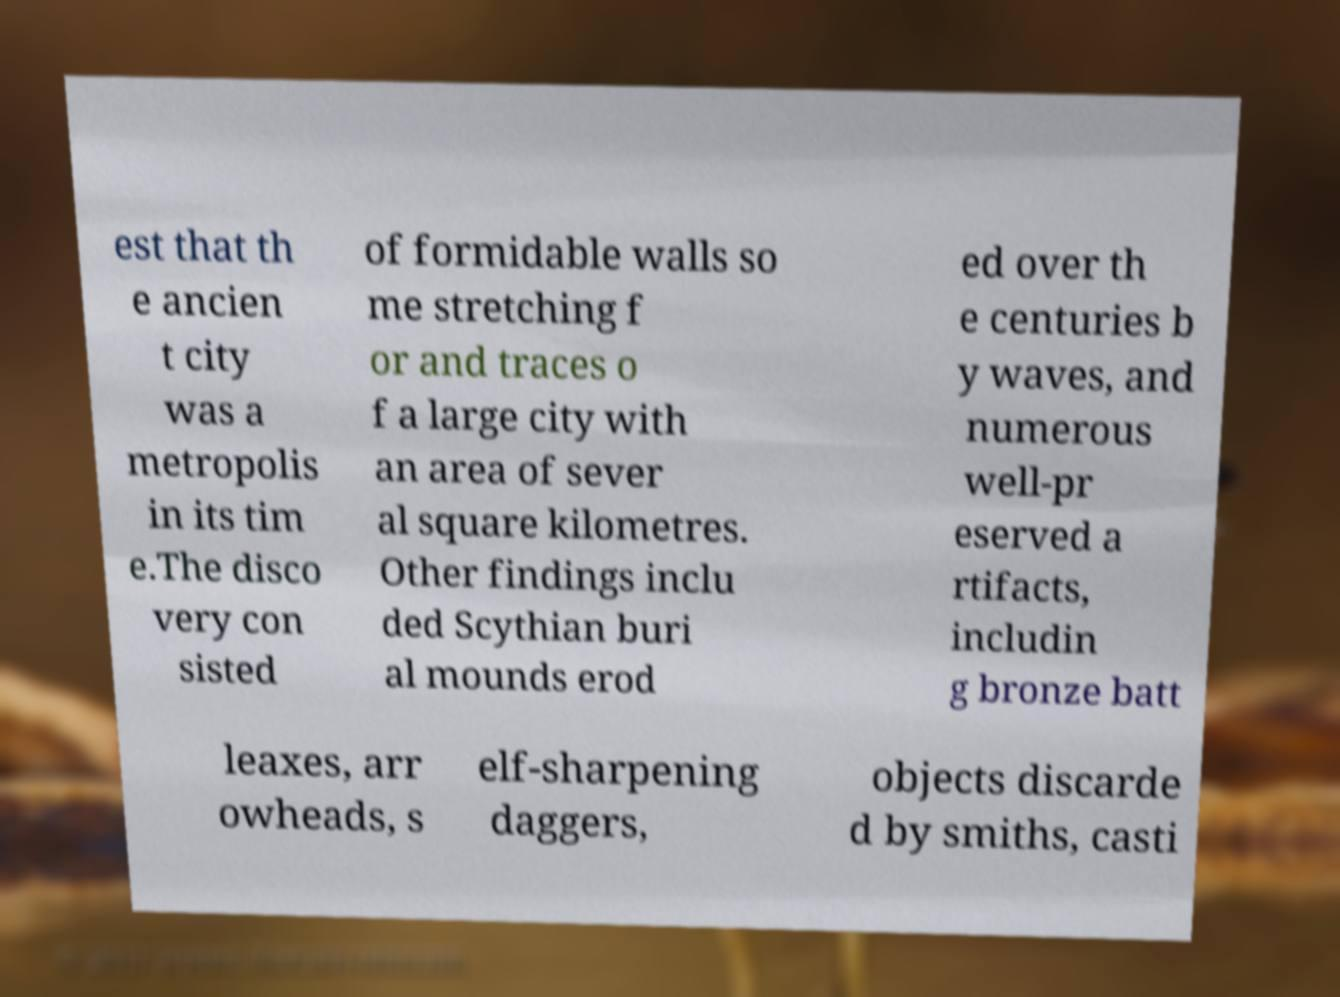Please read and relay the text visible in this image. What does it say? est that th e ancien t city was a metropolis in its tim e.The disco very con sisted of formidable walls so me stretching f or and traces o f a large city with an area of sever al square kilometres. Other findings inclu ded Scythian buri al mounds erod ed over th e centuries b y waves, and numerous well-pr eserved a rtifacts, includin g bronze batt leaxes, arr owheads, s elf-sharpening daggers, objects discarde d by smiths, casti 